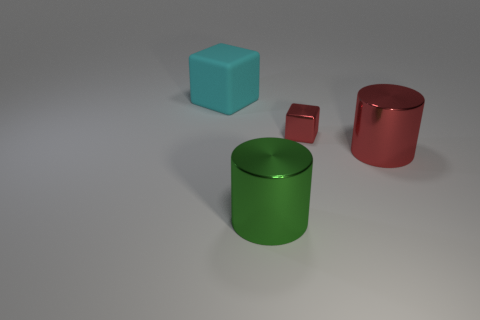Subtract all yellow cylinders. How many purple cubes are left? 0 Subtract all big blue rubber cubes. Subtract all big red metallic cylinders. How many objects are left? 3 Add 3 big red objects. How many big red objects are left? 4 Add 1 small red shiny cubes. How many small red shiny cubes exist? 2 Add 2 small blue cylinders. How many objects exist? 6 Subtract 1 green cylinders. How many objects are left? 3 Subtract 2 cylinders. How many cylinders are left? 0 Subtract all red cylinders. Subtract all brown balls. How many cylinders are left? 1 